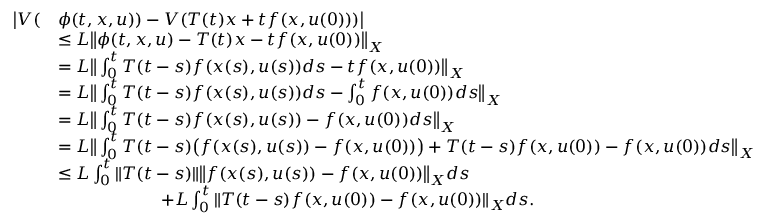<formula> <loc_0><loc_0><loc_500><loc_500>\begin{array} { r l } { \left | V ( } & { \phi ( t , x , u ) ) - V ( T ( t ) x + t f ( x , u ( 0 ) ) ) \right | } \\ & { \leq L \left \| \phi ( t , x , u ) - T ( t ) x - t f ( x , u ( 0 ) ) \right \| _ { X } } \\ & { = L \left \| \int _ { 0 } ^ { t } T ( t - s ) f ( x ( s ) , u ( s ) ) d s - t f ( x , u ( 0 ) ) \right \| _ { X } } \\ & { = L \left \| \int _ { 0 } ^ { t } T ( t - s ) f ( x ( s ) , u ( s ) ) d s - \int _ { 0 } ^ { t } f ( x , u ( 0 ) ) d s \right \| _ { X } } \\ & { = L \left \| \int _ { 0 } ^ { t } T ( t - s ) f ( x ( s ) , u ( s ) ) - f ( x , u ( 0 ) ) d s \right \| _ { X } } \\ & { = L \left \| \int _ { 0 } ^ { t } T ( t - s ) \left ( f ( x ( s ) , u ( s ) ) - f ( x , u ( 0 ) ) \right ) + T ( t - s ) f ( x , u ( 0 ) ) - f ( x , u ( 0 ) ) d s \right \| _ { X } } \\ & { \leq L \int _ { 0 } ^ { t } \| T ( t - s ) \| \left \| f ( x ( s ) , u ( s ) ) - f ( x , u ( 0 ) ) \right \| _ { X } d s } \\ & { \quad + L \int _ { 0 } ^ { t } \| T ( t - s ) f ( x , u ( 0 ) ) - f ( x , u ( 0 ) ) \| _ { X } d s . } \end{array}</formula> 